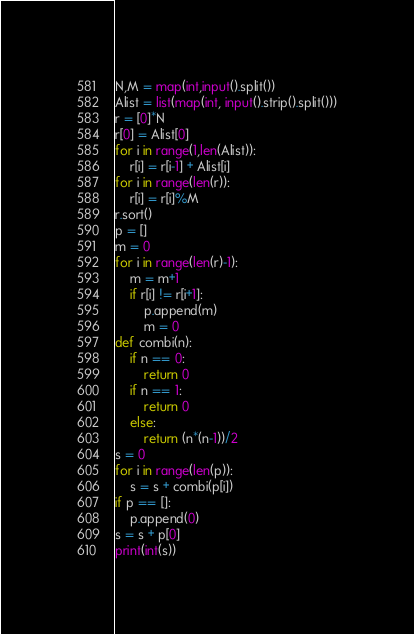Convert code to text. <code><loc_0><loc_0><loc_500><loc_500><_Python_>N,M = map(int,input().split())
Alist = list(map(int, input().strip().split()))
r = [0]*N
r[0] = Alist[0]
for i in range(1,len(Alist)):
    r[i] = r[i-1] + Alist[i]
for i in range(len(r)):
    r[i] = r[i]%M
r.sort()
p = []
m = 0
for i in range(len(r)-1):
    m = m+1
    if r[i] != r[i+1]:
        p.append(m)
        m = 0
def combi(n):
    if n == 0:
        return 0
    if n == 1:
        return 0
    else:
        return (n*(n-1))/2
s = 0
for i in range(len(p)):
    s = s + combi(p[i])
if p == []:
    p.append(0)
s = s + p[0]
print(int(s))</code> 